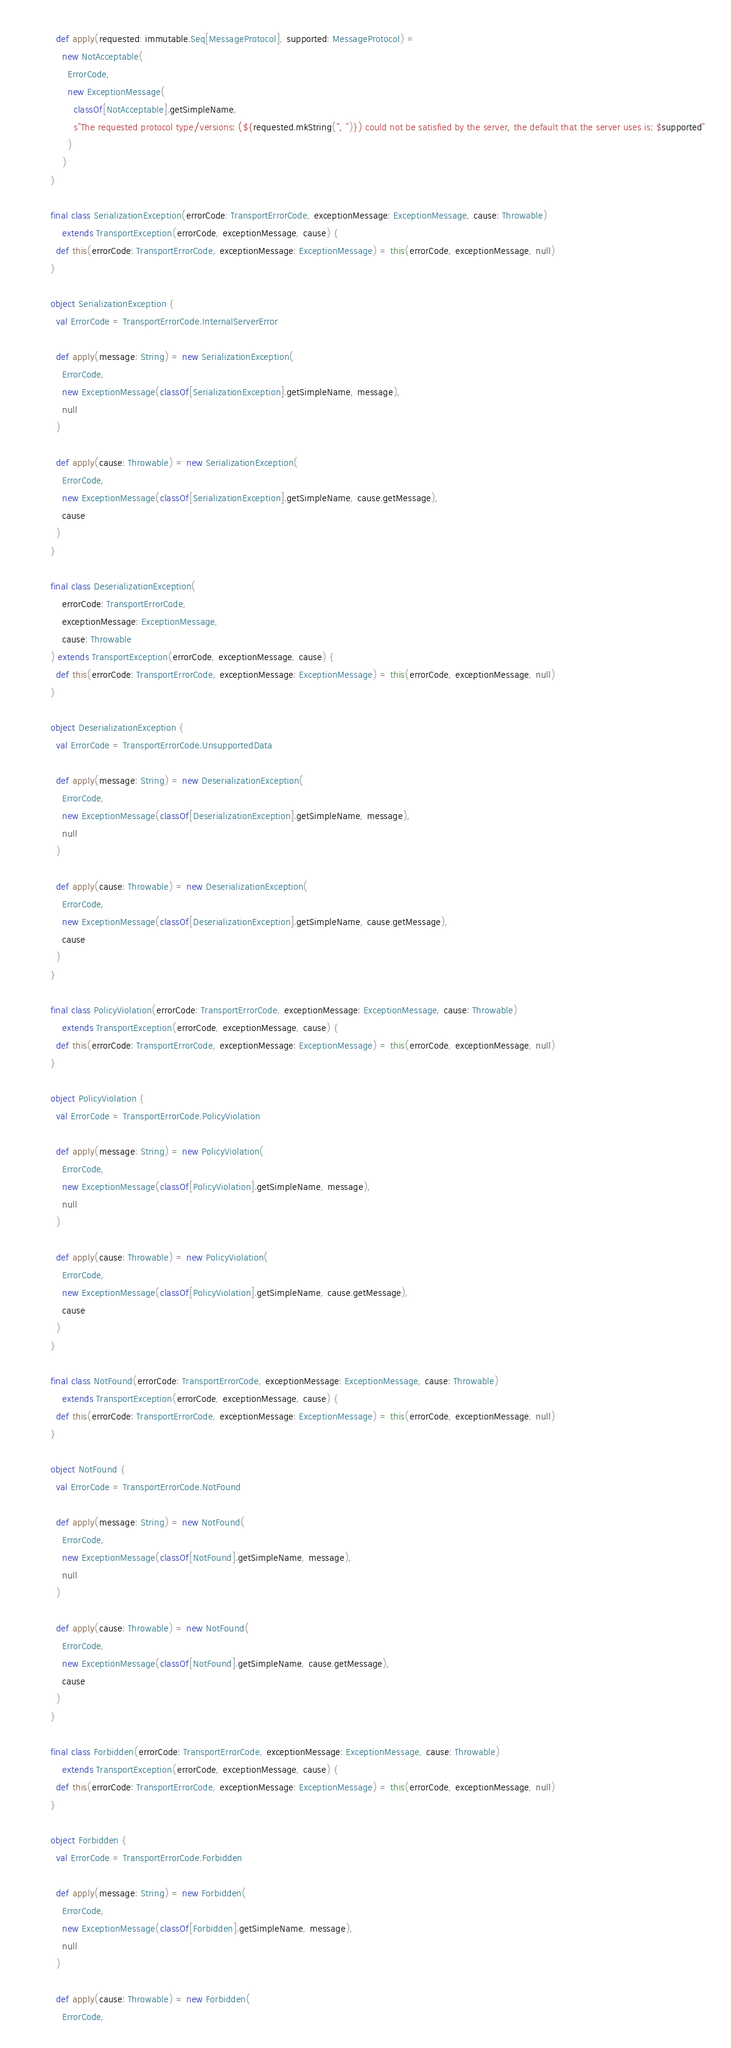<code> <loc_0><loc_0><loc_500><loc_500><_Scala_>
  def apply(requested: immutable.Seq[MessageProtocol], supported: MessageProtocol) =
    new NotAcceptable(
      ErrorCode,
      new ExceptionMessage(
        classOf[NotAcceptable].getSimpleName,
        s"The requested protocol type/versions: (${requested.mkString(", ")}) could not be satisfied by the server, the default that the server uses is: $supported"
      )
    )
}

final class SerializationException(errorCode: TransportErrorCode, exceptionMessage: ExceptionMessage, cause: Throwable)
    extends TransportException(errorCode, exceptionMessage, cause) {
  def this(errorCode: TransportErrorCode, exceptionMessage: ExceptionMessage) = this(errorCode, exceptionMessage, null)
}

object SerializationException {
  val ErrorCode = TransportErrorCode.InternalServerError

  def apply(message: String) = new SerializationException(
    ErrorCode,
    new ExceptionMessage(classOf[SerializationException].getSimpleName, message),
    null
  )

  def apply(cause: Throwable) = new SerializationException(
    ErrorCode,
    new ExceptionMessage(classOf[SerializationException].getSimpleName, cause.getMessage),
    cause
  )
}

final class DeserializationException(
    errorCode: TransportErrorCode,
    exceptionMessage: ExceptionMessage,
    cause: Throwable
) extends TransportException(errorCode, exceptionMessage, cause) {
  def this(errorCode: TransportErrorCode, exceptionMessage: ExceptionMessage) = this(errorCode, exceptionMessage, null)
}

object DeserializationException {
  val ErrorCode = TransportErrorCode.UnsupportedData

  def apply(message: String) = new DeserializationException(
    ErrorCode,
    new ExceptionMessage(classOf[DeserializationException].getSimpleName, message),
    null
  )

  def apply(cause: Throwable) = new DeserializationException(
    ErrorCode,
    new ExceptionMessage(classOf[DeserializationException].getSimpleName, cause.getMessage),
    cause
  )
}

final class PolicyViolation(errorCode: TransportErrorCode, exceptionMessage: ExceptionMessage, cause: Throwable)
    extends TransportException(errorCode, exceptionMessage, cause) {
  def this(errorCode: TransportErrorCode, exceptionMessage: ExceptionMessage) = this(errorCode, exceptionMessage, null)
}

object PolicyViolation {
  val ErrorCode = TransportErrorCode.PolicyViolation

  def apply(message: String) = new PolicyViolation(
    ErrorCode,
    new ExceptionMessage(classOf[PolicyViolation].getSimpleName, message),
    null
  )

  def apply(cause: Throwable) = new PolicyViolation(
    ErrorCode,
    new ExceptionMessage(classOf[PolicyViolation].getSimpleName, cause.getMessage),
    cause
  )
}

final class NotFound(errorCode: TransportErrorCode, exceptionMessage: ExceptionMessage, cause: Throwable)
    extends TransportException(errorCode, exceptionMessage, cause) {
  def this(errorCode: TransportErrorCode, exceptionMessage: ExceptionMessage) = this(errorCode, exceptionMessage, null)
}

object NotFound {
  val ErrorCode = TransportErrorCode.NotFound

  def apply(message: String) = new NotFound(
    ErrorCode,
    new ExceptionMessage(classOf[NotFound].getSimpleName, message),
    null
  )

  def apply(cause: Throwable) = new NotFound(
    ErrorCode,
    new ExceptionMessage(classOf[NotFound].getSimpleName, cause.getMessage),
    cause
  )
}

final class Forbidden(errorCode: TransportErrorCode, exceptionMessage: ExceptionMessage, cause: Throwable)
    extends TransportException(errorCode, exceptionMessage, cause) {
  def this(errorCode: TransportErrorCode, exceptionMessage: ExceptionMessage) = this(errorCode, exceptionMessage, null)
}

object Forbidden {
  val ErrorCode = TransportErrorCode.Forbidden

  def apply(message: String) = new Forbidden(
    ErrorCode,
    new ExceptionMessage(classOf[Forbidden].getSimpleName, message),
    null
  )

  def apply(cause: Throwable) = new Forbidden(
    ErrorCode,</code> 